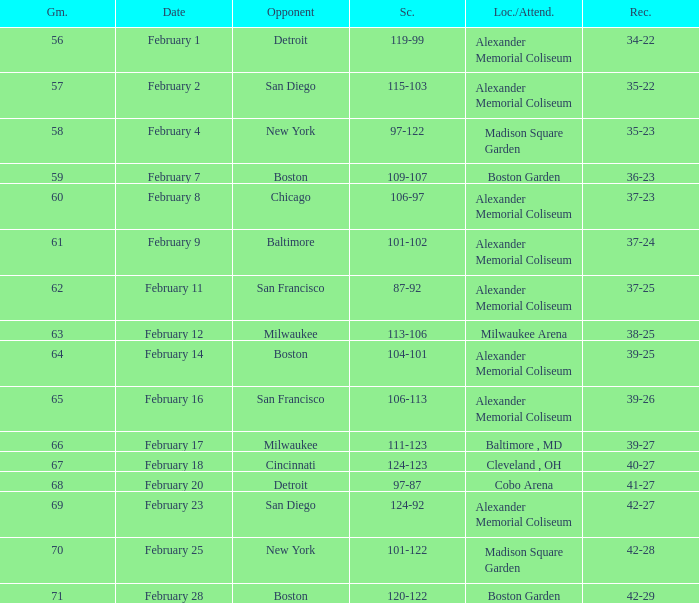What is the Game # that scored 87-92? 62.0. 